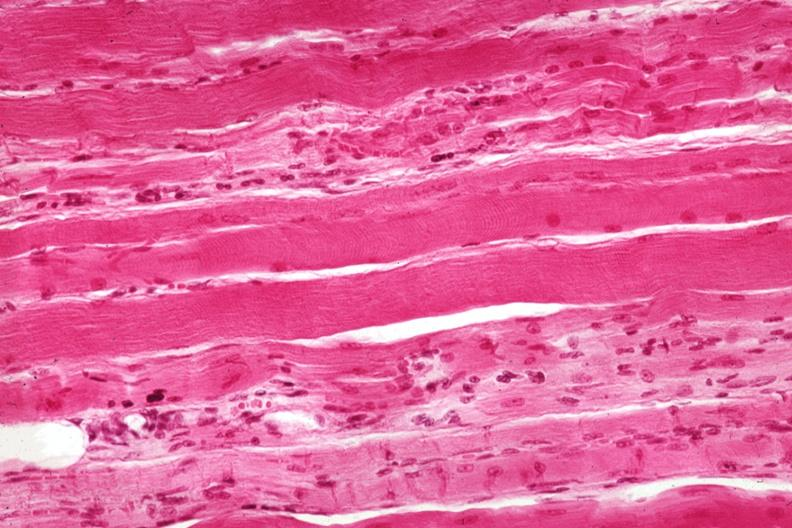what is present?
Answer the question using a single word or phrase. Muscle 